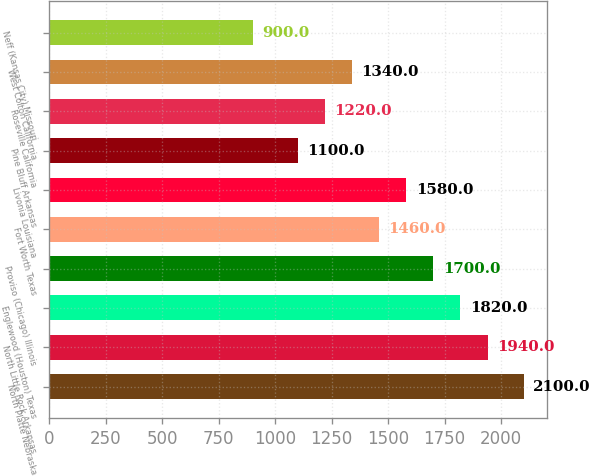Convert chart to OTSL. <chart><loc_0><loc_0><loc_500><loc_500><bar_chart><fcel>North Platte Nebraska<fcel>North Little Rock Arkansas<fcel>Englewood (Houston) Texas<fcel>Proviso (Chicago) Illinois<fcel>Fort Worth Texas<fcel>Livonia Louisiana<fcel>Pine Bluff Arkansas<fcel>Roseville California<fcel>West Colton California<fcel>Neff (Kansas City) Missouri<nl><fcel>2100<fcel>1940<fcel>1820<fcel>1700<fcel>1460<fcel>1580<fcel>1100<fcel>1220<fcel>1340<fcel>900<nl></chart> 